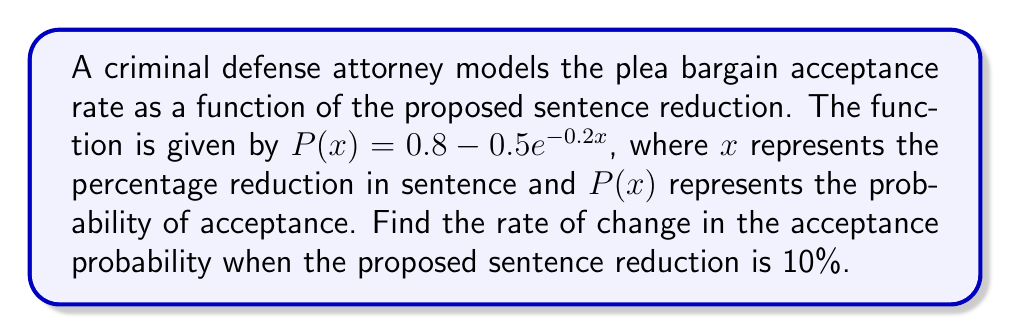Teach me how to tackle this problem. To find the rate of change in the acceptance probability when the proposed sentence reduction is 10%, we need to calculate the derivative of the function $P(x)$ and evaluate it at $x = 10$.

Step 1: Calculate the derivative of $P(x)$
$$\frac{d}{dx}P(x) = \frac{d}{dx}(0.8 - 0.5e^{-0.2x})$$
$$P'(x) = 0 - 0.5 \cdot \frac{d}{dx}(e^{-0.2x})$$
$$P'(x) = -0.5 \cdot (-0.2e^{-0.2x})$$
$$P'(x) = 0.1e^{-0.2x}$$

Step 2: Evaluate $P'(x)$ at $x = 10$
$$P'(10) = 0.1e^{-0.2(10)}$$
$$P'(10) = 0.1e^{-2}$$
$$P'(10) \approx 0.0135$$

This result represents the instantaneous rate of change in the acceptance probability when the proposed sentence reduction is 10%.
Answer: $0.1e^{-2}$ or approximately $0.0135$ 